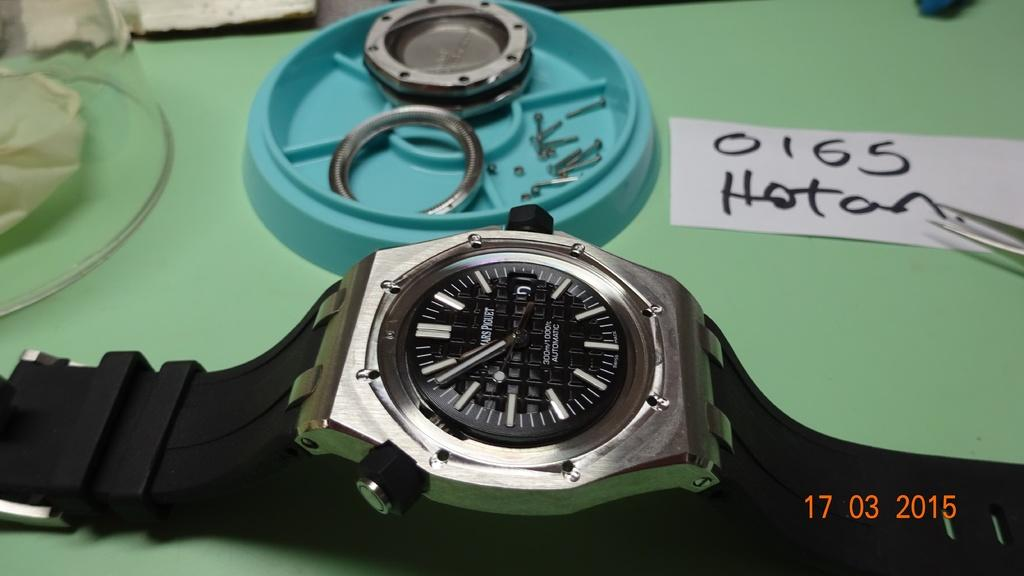<image>
Share a concise interpretation of the image provided. A watch is on the table and behind it is a piece of paper with the numbers 0165 written on it. 